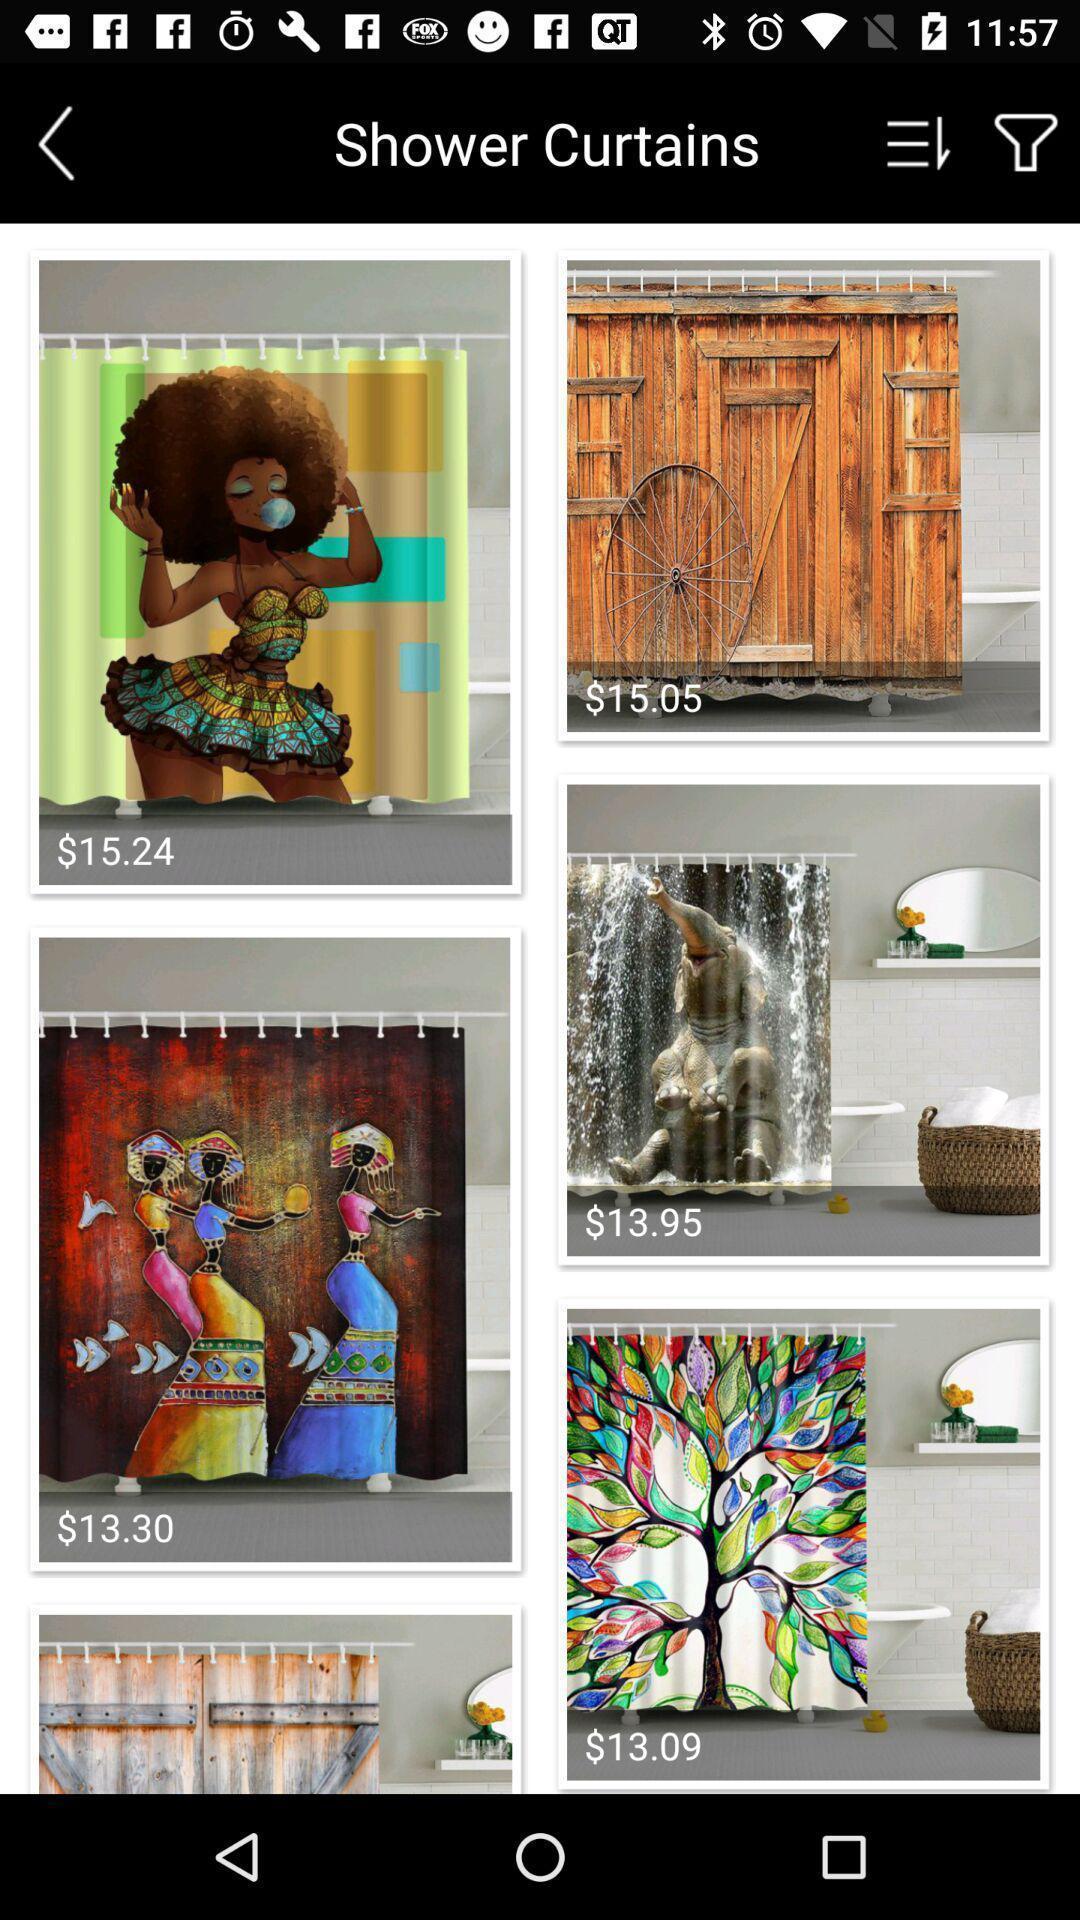What can you discern from this picture? Screen showing page of an shopping application. 